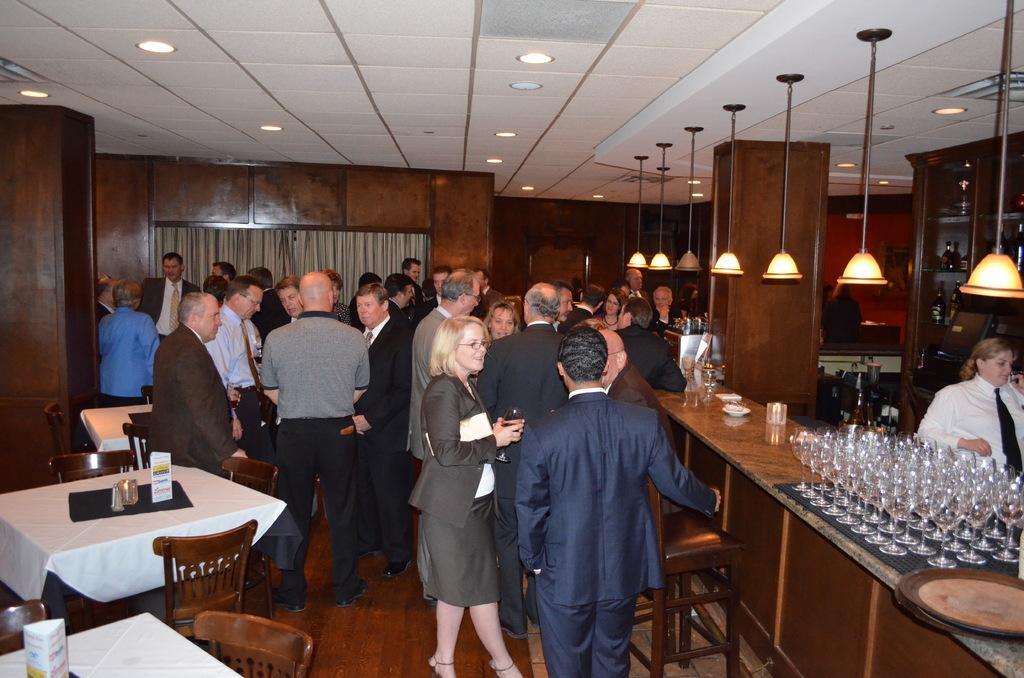Could you give a brief overview of what you see in this image? There are group of people standing and talking to each other. These are wine glasses placed on the desk. This is a table covered with white cloth with some objects on it. These are the lamps hanging through the rooftop. 